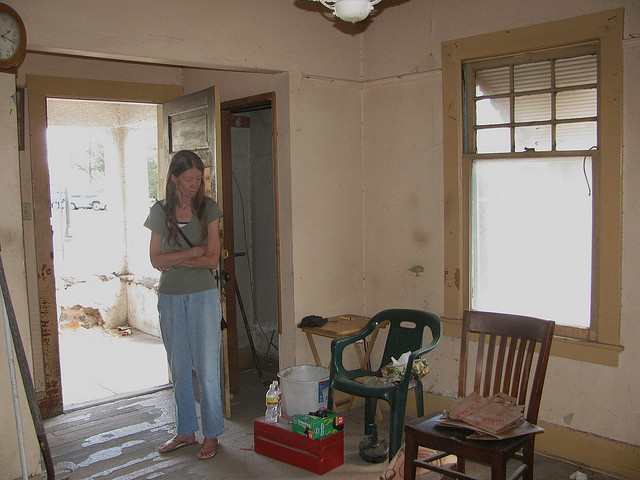Describe the objects in this image and their specific colors. I can see people in gray, maroon, and black tones, chair in gray, black, and maroon tones, chair in gray, black, and maroon tones, clock in gray, maroon, and black tones, and car in gray, lightgray, darkgray, and lightblue tones in this image. 